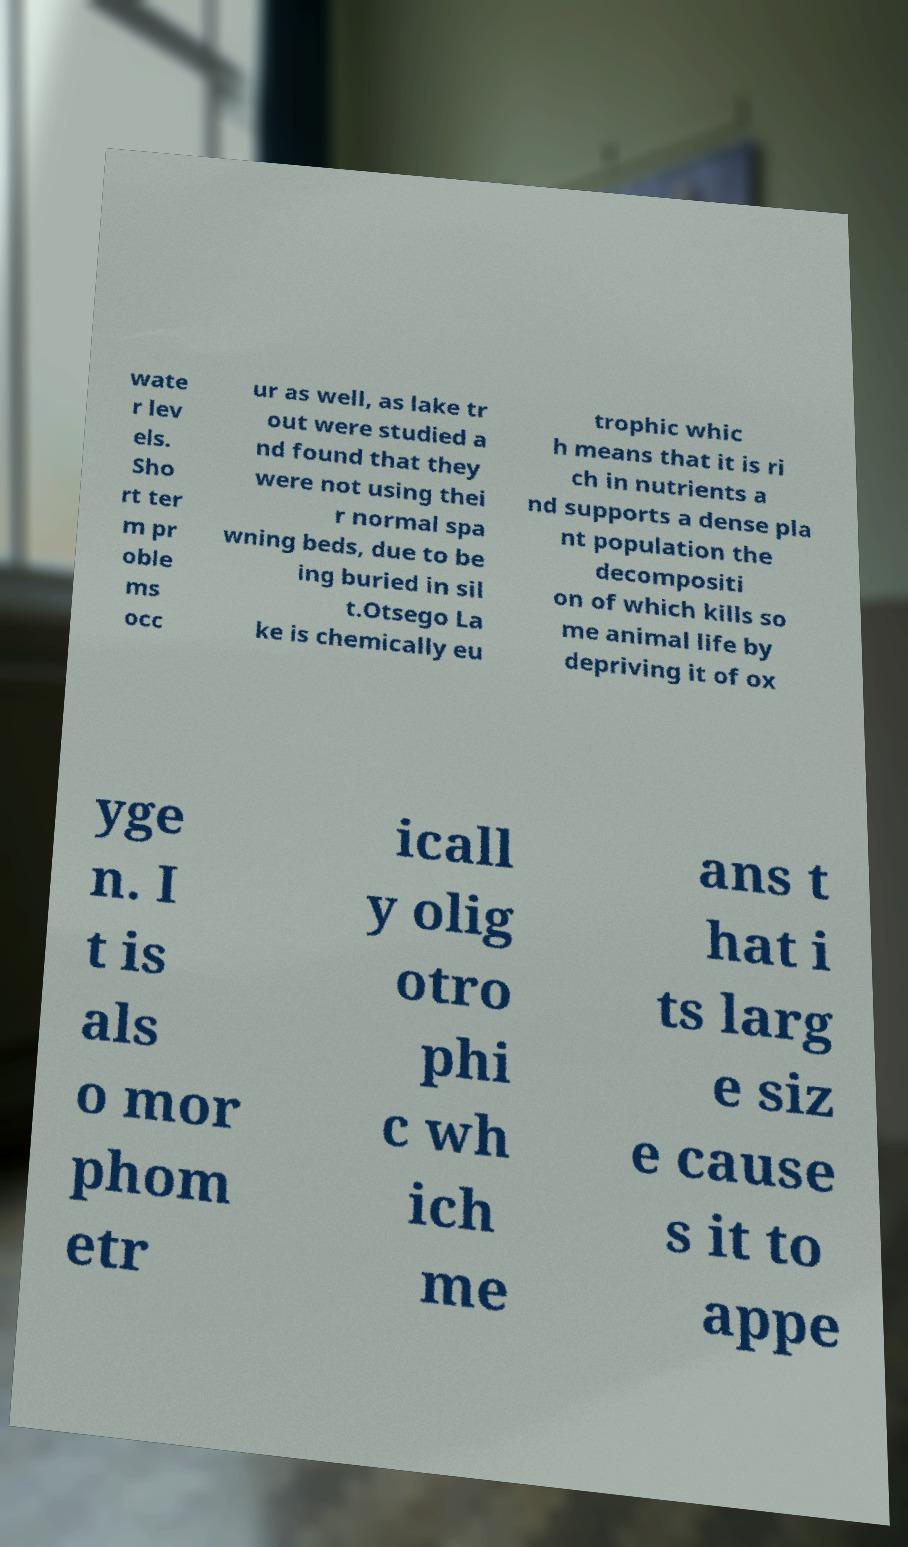Could you assist in decoding the text presented in this image and type it out clearly? wate r lev els. Sho rt ter m pr oble ms occ ur as well, as lake tr out were studied a nd found that they were not using thei r normal spa wning beds, due to be ing buried in sil t.Otsego La ke is chemically eu trophic whic h means that it is ri ch in nutrients a nd supports a dense pla nt population the decompositi on of which kills so me animal life by depriving it of ox yge n. I t is als o mor phom etr icall y olig otro phi c wh ich me ans t hat i ts larg e siz e cause s it to appe 